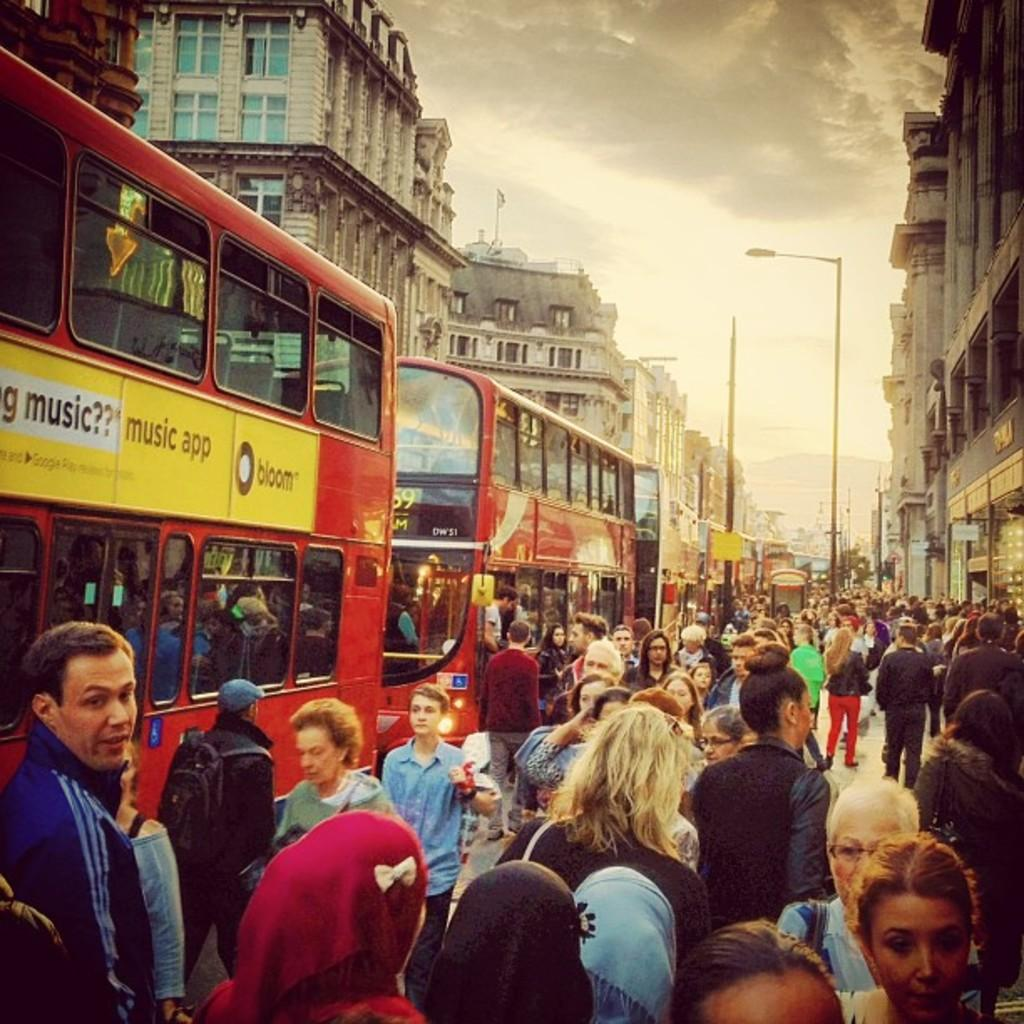<image>
Offer a succinct explanation of the picture presented. Busy street with two double decker buses with a yellow sign with the black letters music app. 